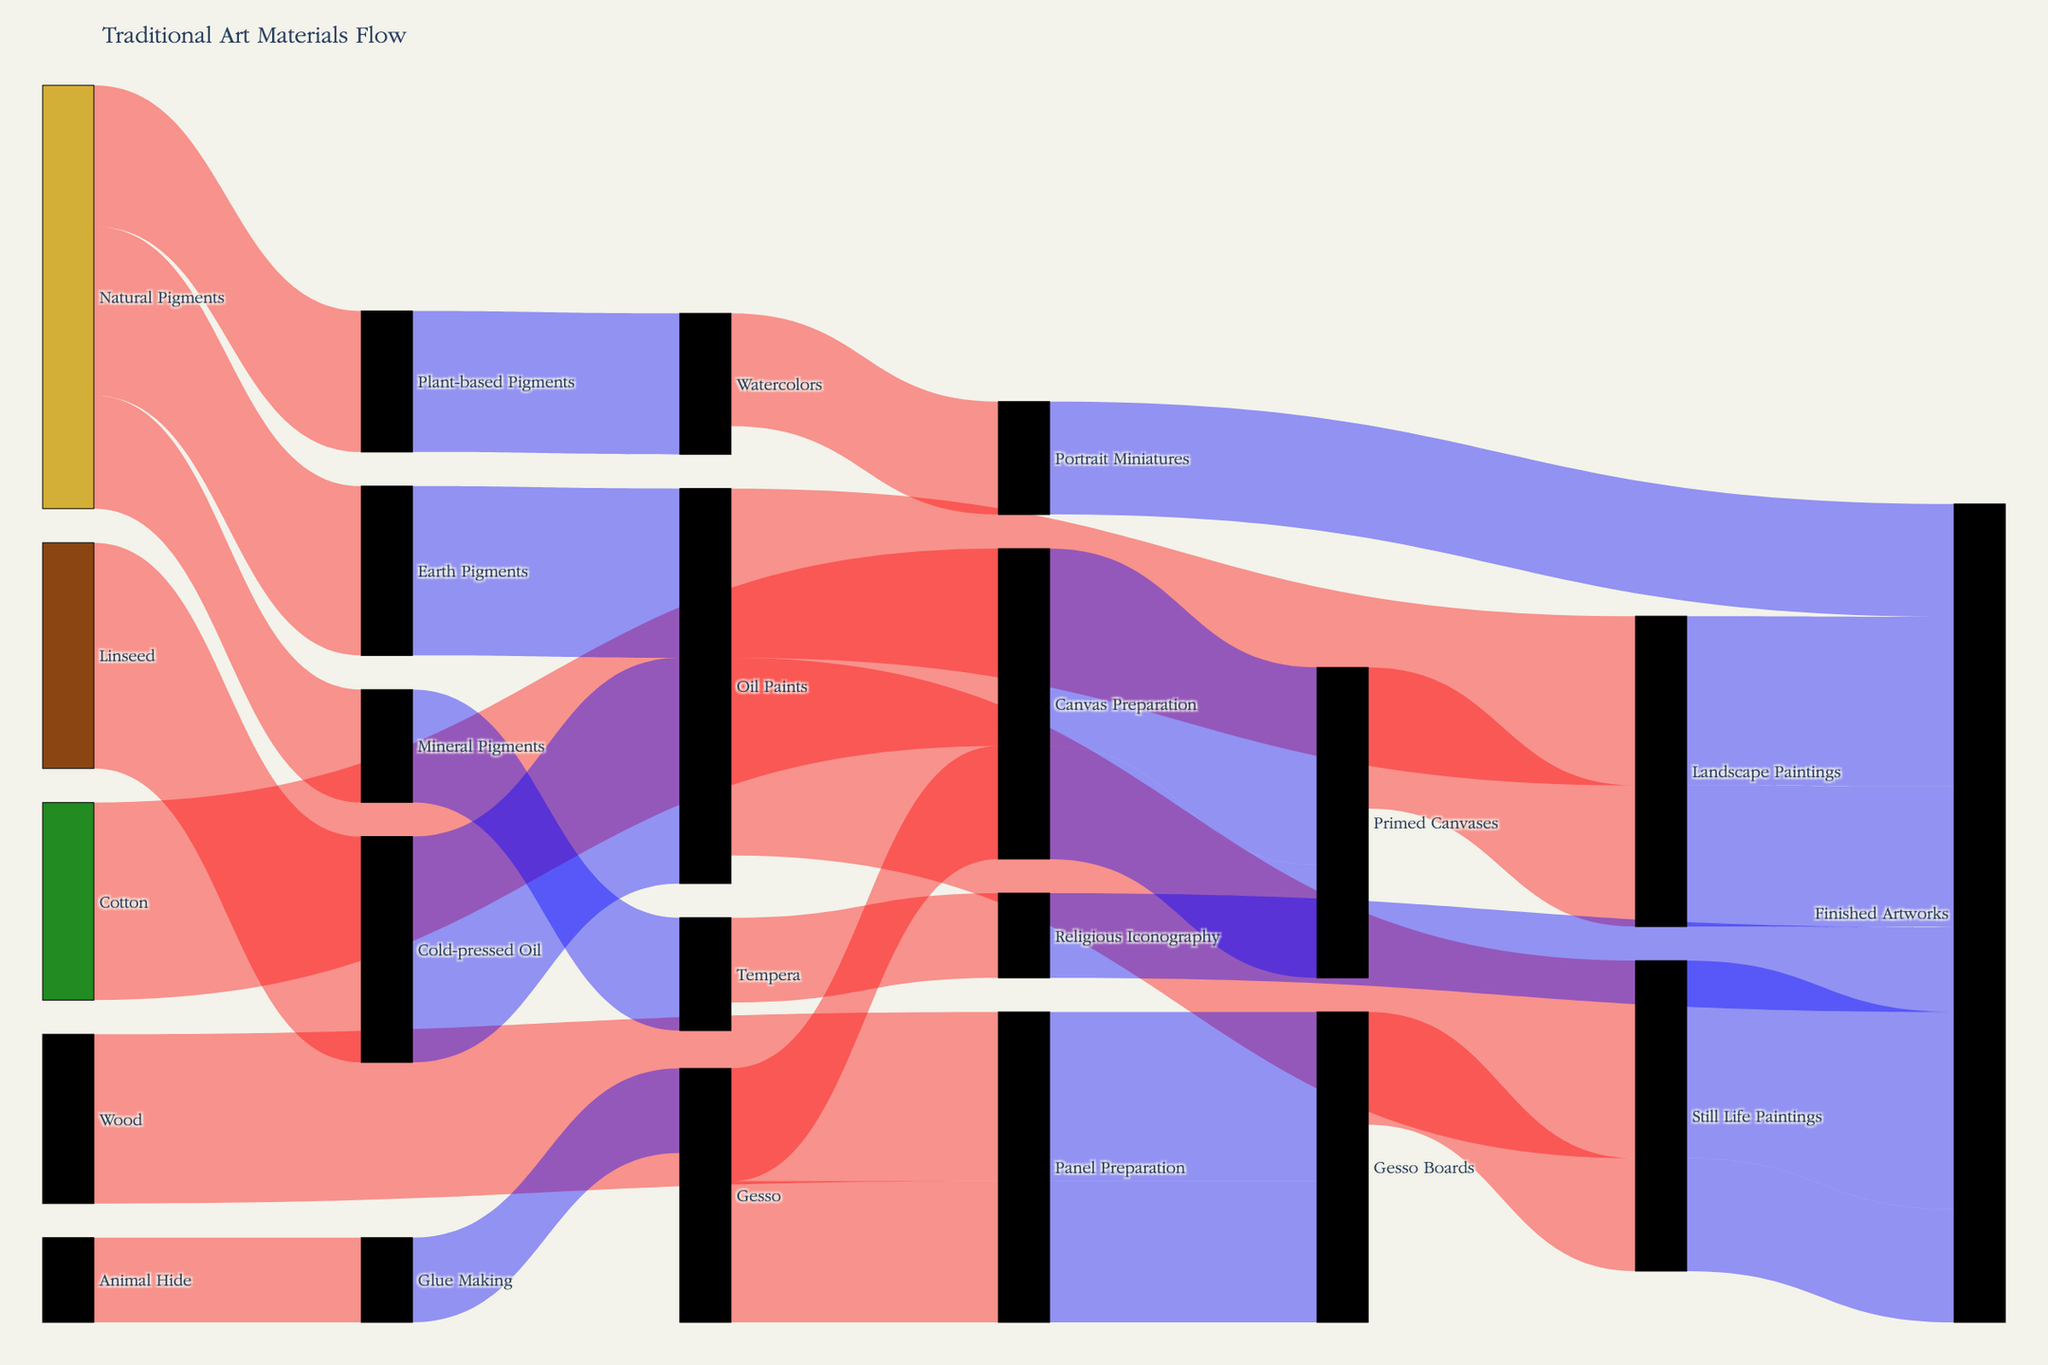What is the title of the Sankey Diagram? The title is usually located at the top center of the figure. In this case, it clearly states the subject of the Sankey Diagram.
Answer: Traditional Art Materials Flow Which material has the highest value in contributing to "Oil Paints"? To answer this, we need to check the connections leading to "Oil Paints" and compare their values. "Natural Pigments" contributes 30, while "Linseed" contributes 40.
Answer: Linseed How many finished artworks are produced from landscape paintings? We need to follow the flow from "Landscape Paintings" to "Finished Artworks" and note the value. The connection shows a value of 25.
Answer: 25 What is the total value of materials sourced from "Natural Pigments"? Summing up the values for "Natural Pigments" to various intermediates: Earth Pigments (30), Plant-based Pigments (25), Mineral Pigments (20). 30 + 25 + 20 = 75.
Answer: 75 Which destination has more finished artworks, "Still Life Paintings" or "Landscape Paintings"? Comparing the values of finished artworks: "Still Life Paintings" produces 35, while "Landscape Paintings" produces 25.
Answer: Still Life Paintings Between "Oil Paints" and "Tempera," which has a broader range of intermediate sources? "Oil Paints" comes from "Natural Pigments" and "Cold-pressed Oil" (2 sources), whereas "Tempera" comes only from "Mineral Pigments" (1 source).
Answer: Oil Paints What is the total value of "Finished Artworks" derived from "Oil Paints"? To calculate this, sum up the values from "Oil Paints" to "Still Life Paintings" (35) and "Landscape Paintings" (30). 35 + 30 = 65.
Answer: 65 How much "Gesso" is used in "Panel Preparation"? Look at the path from "Gesso" to "Panel Preparation" and observe the value, which is 25.
Answer: 25 Which intermediate has the highest total input value from different sources? We must sum up the inputs for each intermediate. "Canvas Preparation" gets 35 (Cotton) + 20 (Gesso) = 55; "Panel Preparation" gets 30 (Wood) + 25 (Gesso) = 55; others have lower values.
Answer: Tie between Canvas Preparation and Panel Preparation How many interconnected nodes are combined to result in "Primed Canvases"? We need to follow the connections to "Primed Canvases". It sources from "Canvas Preparation", involving "Cotton" and "Gesso", so it's 3 nodes total.
Answer: 3 nodes 